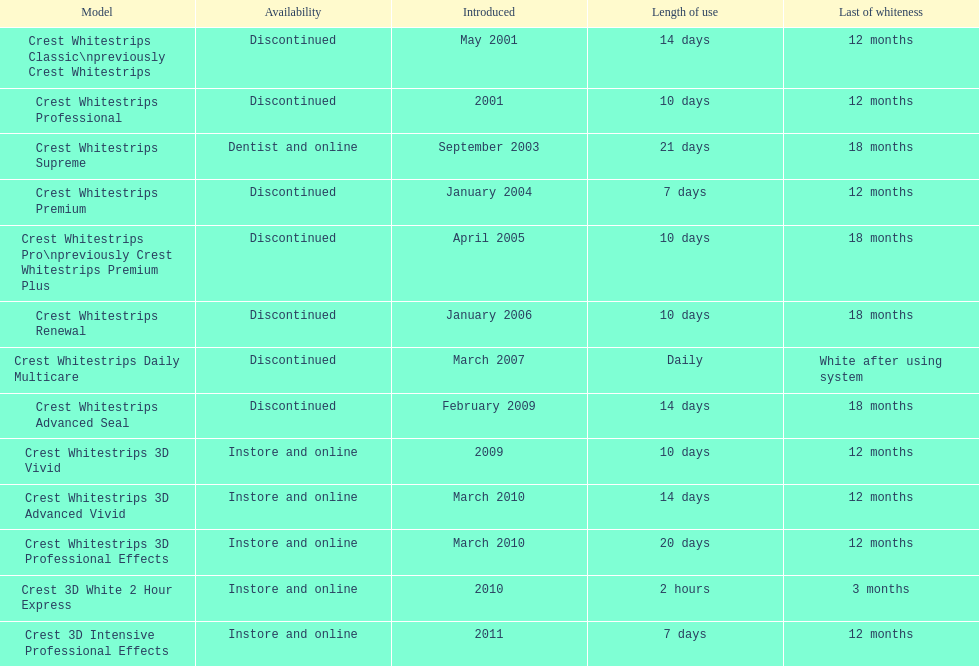Which model has the highest 'length of use' to 'last of whiteness' ratio? Crest Whitestrips Supreme. 